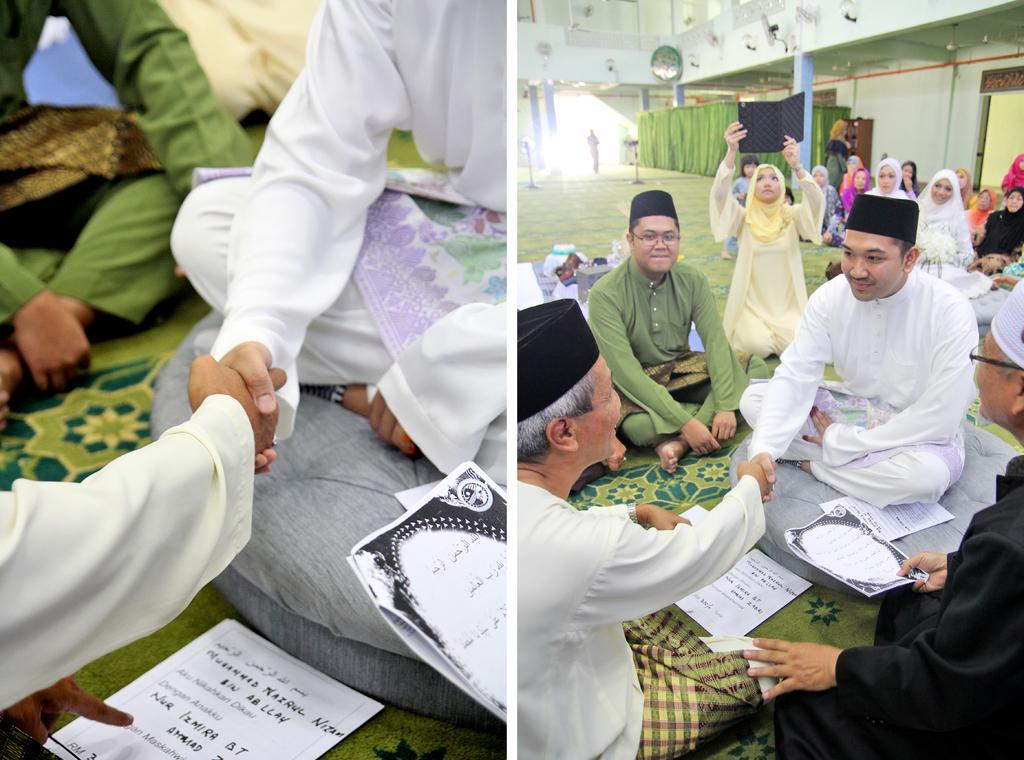How was the image altered or modified? The image is edited, which means it has been changed or manipulated in some way. What type of institution is depicted in the image? There is a college in the image. How many cards are being held by the duck in the image? There is no duck present in the image, and therefore no cards can be held by a duck. 